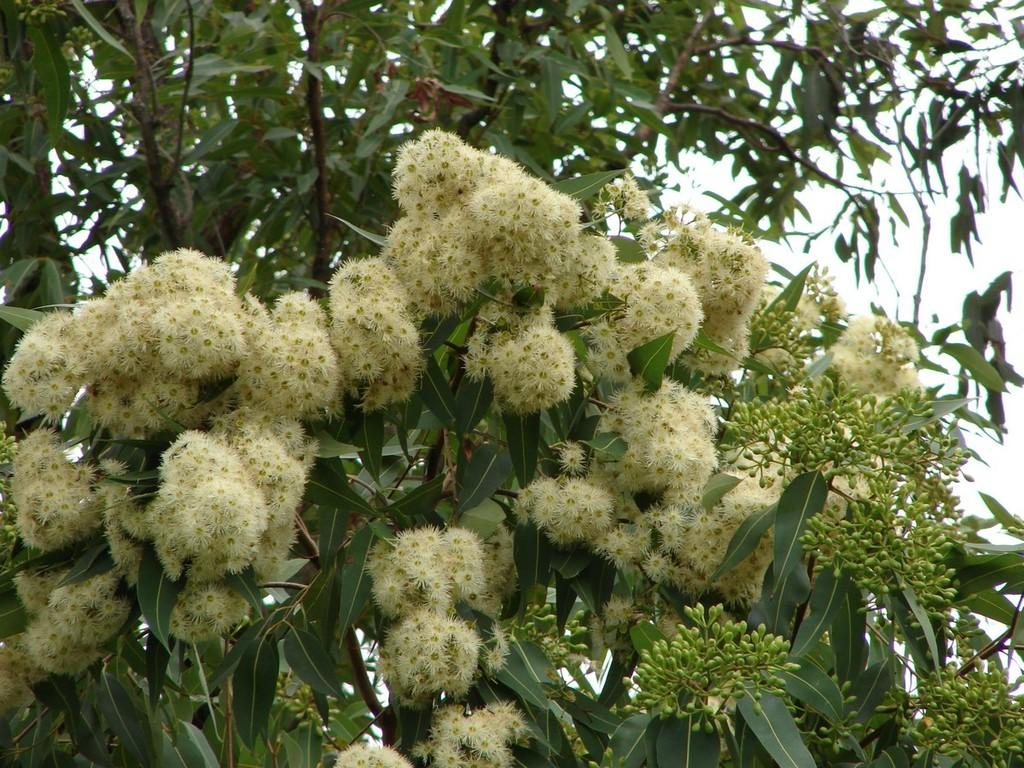What is the main subject of the image? The main subject of the image is a bunch of flowers. Where are the flowers located? The flowers are on a tree. What type of jewel is hanging from the tree in the image? There is no jewel present in the image; it features a bunch of flowers on a tree. On which side of the tree are the flowers located? The provided facts do not specify the side of the tree where the flowers are located, so it cannot be determined from the image. 